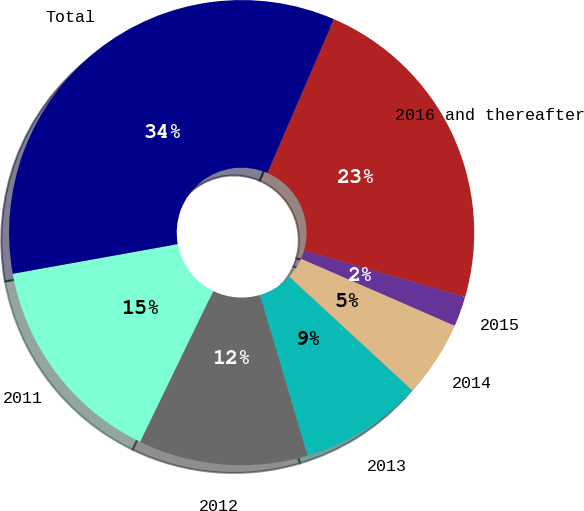<chart> <loc_0><loc_0><loc_500><loc_500><pie_chart><fcel>2011<fcel>2012<fcel>2013<fcel>2014<fcel>2015<fcel>2016 and thereafter<fcel>Total<nl><fcel>14.99%<fcel>11.77%<fcel>8.54%<fcel>5.32%<fcel>2.1%<fcel>22.96%<fcel>34.33%<nl></chart> 